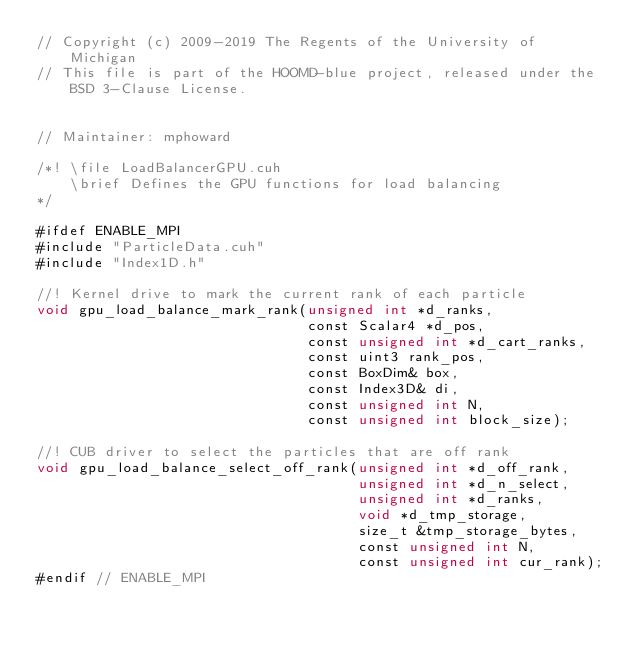<code> <loc_0><loc_0><loc_500><loc_500><_Cuda_>// Copyright (c) 2009-2019 The Regents of the University of Michigan
// This file is part of the HOOMD-blue project, released under the BSD 3-Clause License.


// Maintainer: mphoward

/*! \file LoadBalancerGPU.cuh
    \brief Defines the GPU functions for load balancing
*/

#ifdef ENABLE_MPI
#include "ParticleData.cuh"
#include "Index1D.h"

//! Kernel drive to mark the current rank of each particle
void gpu_load_balance_mark_rank(unsigned int *d_ranks,
                                const Scalar4 *d_pos,
                                const unsigned int *d_cart_ranks,
                                const uint3 rank_pos,
                                const BoxDim& box,
                                const Index3D& di,
                                const unsigned int N,
                                const unsigned int block_size);

//! CUB driver to select the particles that are off rank
void gpu_load_balance_select_off_rank(unsigned int *d_off_rank,
                                      unsigned int *d_n_select,
                                      unsigned int *d_ranks,
                                      void *d_tmp_storage,
                                      size_t &tmp_storage_bytes,
                                      const unsigned int N,
                                      const unsigned int cur_rank);
#endif // ENABLE_MPI
</code> 